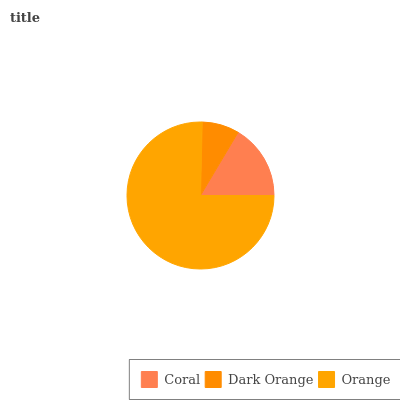Is Dark Orange the minimum?
Answer yes or no. Yes. Is Orange the maximum?
Answer yes or no. Yes. Is Orange the minimum?
Answer yes or no. No. Is Dark Orange the maximum?
Answer yes or no. No. Is Orange greater than Dark Orange?
Answer yes or no. Yes. Is Dark Orange less than Orange?
Answer yes or no. Yes. Is Dark Orange greater than Orange?
Answer yes or no. No. Is Orange less than Dark Orange?
Answer yes or no. No. Is Coral the high median?
Answer yes or no. Yes. Is Coral the low median?
Answer yes or no. Yes. Is Dark Orange the high median?
Answer yes or no. No. Is Orange the low median?
Answer yes or no. No. 